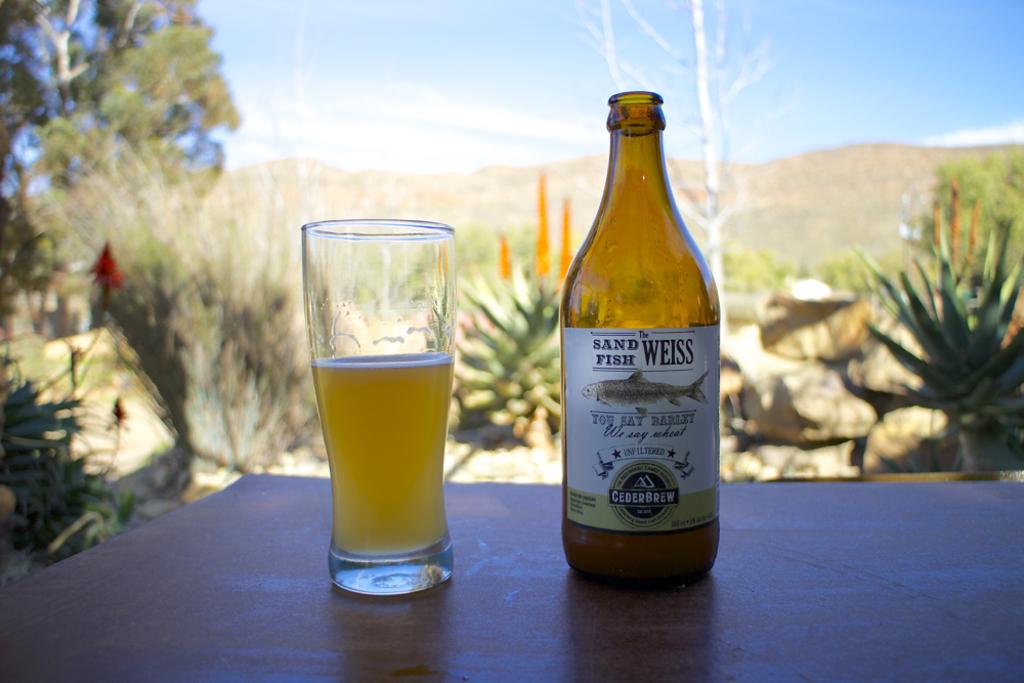What kind of fish is on the label?
Make the answer very short. Sand fish. Is this cederbrew?
Your response must be concise. Yes. 